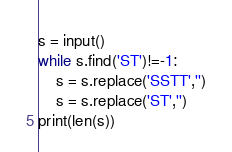Convert code to text. <code><loc_0><loc_0><loc_500><loc_500><_Python_>s = input()
while s.find('ST')!=-1:
    s = s.replace('SSTT','')
    s = s.replace('ST','')
print(len(s))
</code> 